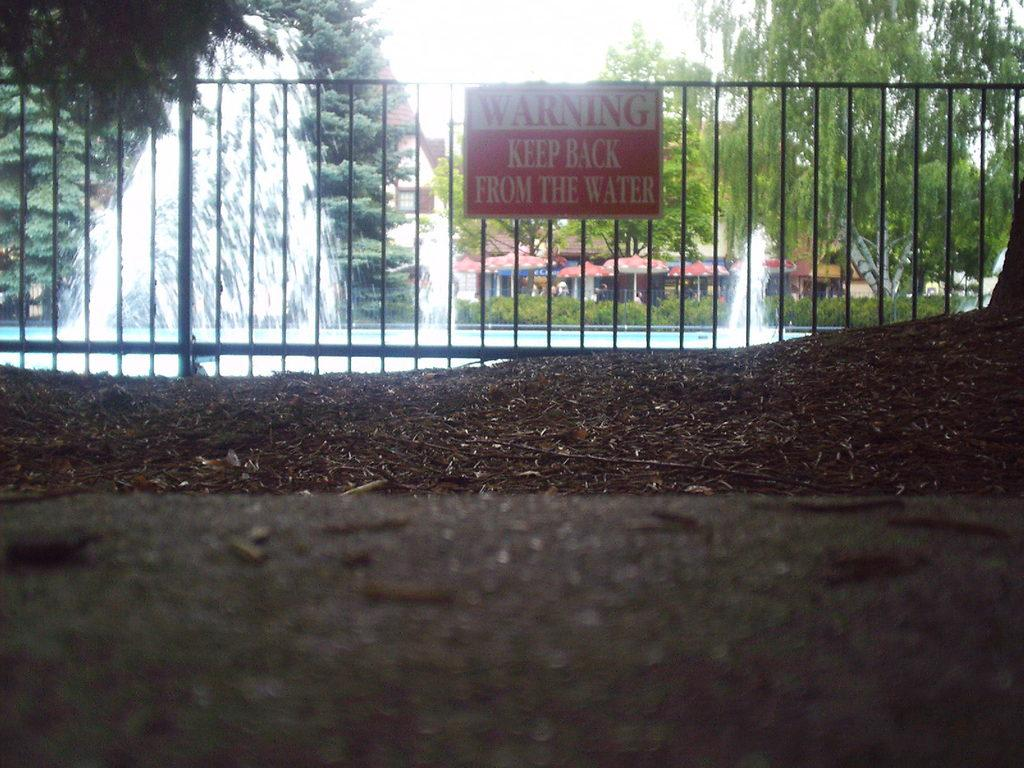What is located in the center of the image? There is a fence in the center of the image. What is written or displayed on the board in the image? There is a board with text in the image. What type of vegetation is visible behind the fence? There are trees behind the fence. What type of temporary shelter can be seen in the image? There are tents in the image. What natural feature is present in the image? There is a waterfall in the image. What reason does the club have for being in the image? There is no mention of a club in the image or the provided facts, so it is not possible to determine a reason for its presence. 